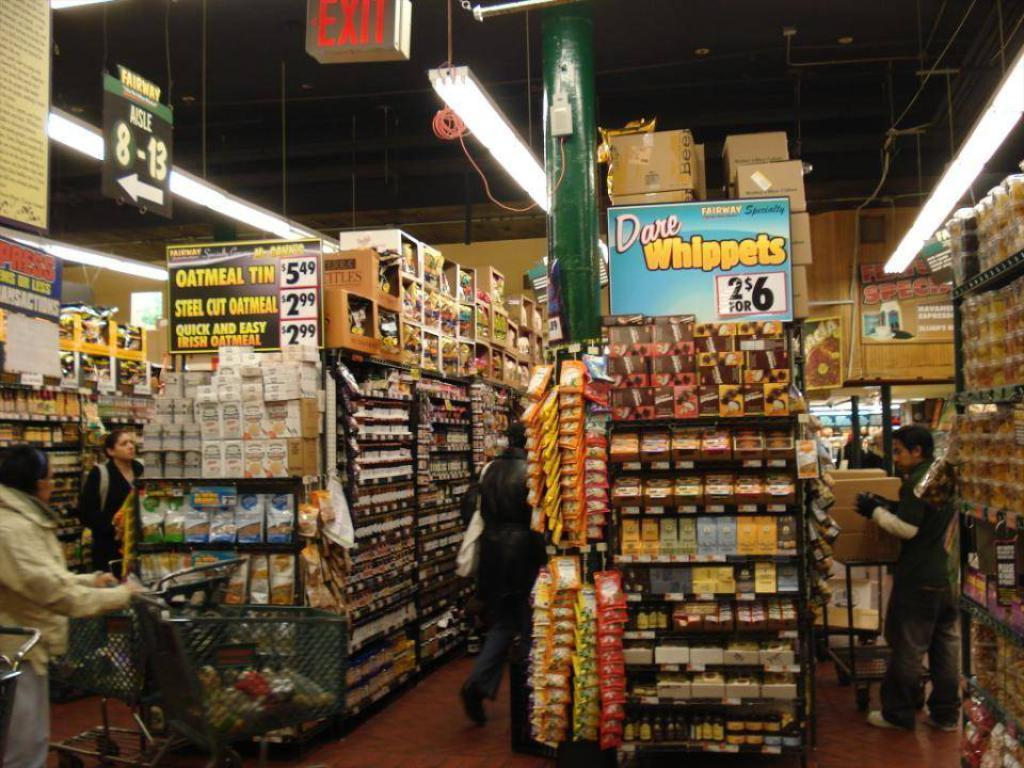<image>
Summarize the visual content of the image. A cluttered store with the sign for Dare Whippets above one of the shelves 